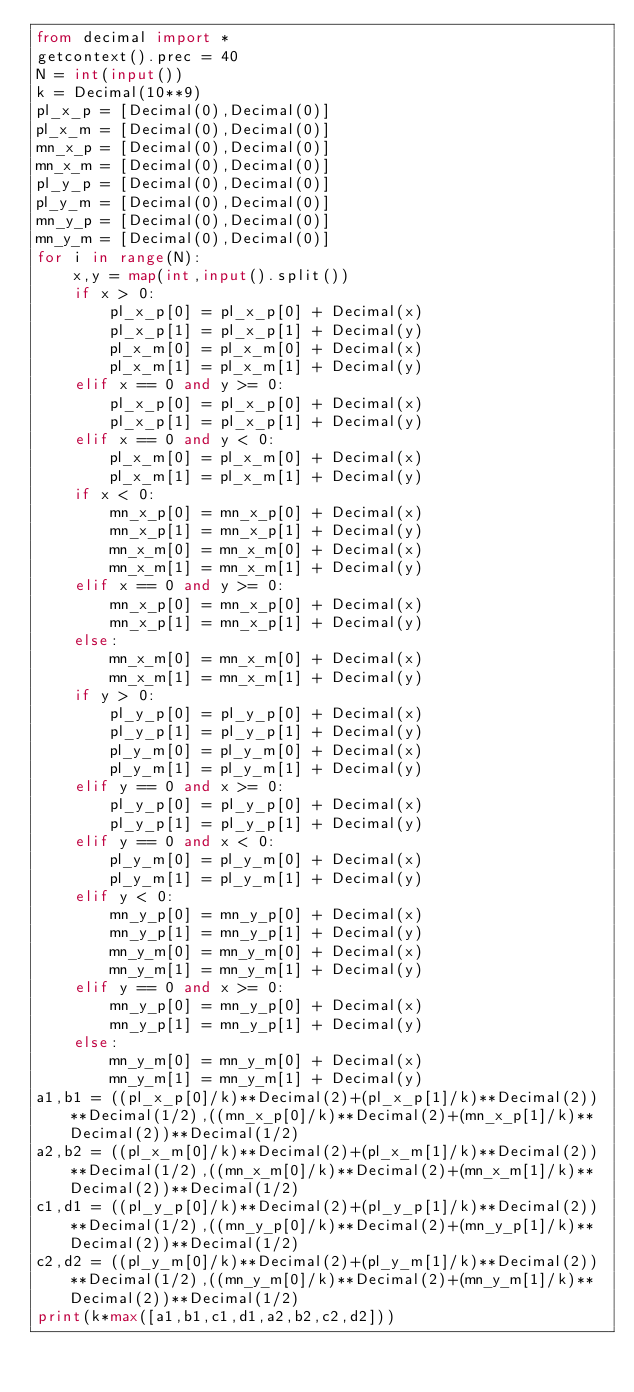<code> <loc_0><loc_0><loc_500><loc_500><_Python_>from decimal import *
getcontext().prec = 40
N = int(input())
k = Decimal(10**9)
pl_x_p = [Decimal(0),Decimal(0)]
pl_x_m = [Decimal(0),Decimal(0)]
mn_x_p = [Decimal(0),Decimal(0)]
mn_x_m = [Decimal(0),Decimal(0)]
pl_y_p = [Decimal(0),Decimal(0)]
pl_y_m = [Decimal(0),Decimal(0)]
mn_y_p = [Decimal(0),Decimal(0)]
mn_y_m = [Decimal(0),Decimal(0)]
for i in range(N):
    x,y = map(int,input().split())
    if x > 0:
        pl_x_p[0] = pl_x_p[0] + Decimal(x)
        pl_x_p[1] = pl_x_p[1] + Decimal(y)
        pl_x_m[0] = pl_x_m[0] + Decimal(x)
        pl_x_m[1] = pl_x_m[1] + Decimal(y)
    elif x == 0 and y >= 0:
        pl_x_p[0] = pl_x_p[0] + Decimal(x)
        pl_x_p[1] = pl_x_p[1] + Decimal(y)
    elif x == 0 and y < 0:
        pl_x_m[0] = pl_x_m[0] + Decimal(x)
        pl_x_m[1] = pl_x_m[1] + Decimal(y)
    if x < 0:
        mn_x_p[0] = mn_x_p[0] + Decimal(x)
        mn_x_p[1] = mn_x_p[1] + Decimal(y)
        mn_x_m[0] = mn_x_m[0] + Decimal(x)
        mn_x_m[1] = mn_x_m[1] + Decimal(y)
    elif x == 0 and y >= 0:
        mn_x_p[0] = mn_x_p[0] + Decimal(x)
        mn_x_p[1] = mn_x_p[1] + Decimal(y)
    else:
        mn_x_m[0] = mn_x_m[0] + Decimal(x)
        mn_x_m[1] = mn_x_m[1] + Decimal(y)
    if y > 0:
        pl_y_p[0] = pl_y_p[0] + Decimal(x)
        pl_y_p[1] = pl_y_p[1] + Decimal(y)
        pl_y_m[0] = pl_y_m[0] + Decimal(x)
        pl_y_m[1] = pl_y_m[1] + Decimal(y)
    elif y == 0 and x >= 0:
        pl_y_p[0] = pl_y_p[0] + Decimal(x)
        pl_y_p[1] = pl_y_p[1] + Decimal(y)
    elif y == 0 and x < 0:
        pl_y_m[0] = pl_y_m[0] + Decimal(x)
        pl_y_m[1] = pl_y_m[1] + Decimal(y)
    elif y < 0:
        mn_y_p[0] = mn_y_p[0] + Decimal(x)
        mn_y_p[1] = mn_y_p[1] + Decimal(y)
        mn_y_m[0] = mn_y_m[0] + Decimal(x)
        mn_y_m[1] = mn_y_m[1] + Decimal(y)
    elif y == 0 and x >= 0:
        mn_y_p[0] = mn_y_p[0] + Decimal(x)
        mn_y_p[1] = mn_y_p[1] + Decimal(y)
    else:
        mn_y_m[0] = mn_y_m[0] + Decimal(x)
        mn_y_m[1] = mn_y_m[1] + Decimal(y)
a1,b1 = ((pl_x_p[0]/k)**Decimal(2)+(pl_x_p[1]/k)**Decimal(2))**Decimal(1/2),((mn_x_p[0]/k)**Decimal(2)+(mn_x_p[1]/k)**Decimal(2))**Decimal(1/2)
a2,b2 = ((pl_x_m[0]/k)**Decimal(2)+(pl_x_m[1]/k)**Decimal(2))**Decimal(1/2),((mn_x_m[0]/k)**Decimal(2)+(mn_x_m[1]/k)**Decimal(2))**Decimal(1/2)
c1,d1 = ((pl_y_p[0]/k)**Decimal(2)+(pl_y_p[1]/k)**Decimal(2))**Decimal(1/2),((mn_y_p[0]/k)**Decimal(2)+(mn_y_p[1]/k)**Decimal(2))**Decimal(1/2)
c2,d2 = ((pl_y_m[0]/k)**Decimal(2)+(pl_y_m[1]/k)**Decimal(2))**Decimal(1/2),((mn_y_m[0]/k)**Decimal(2)+(mn_y_m[1]/k)**Decimal(2))**Decimal(1/2)
print(k*max([a1,b1,c1,d1,a2,b2,c2,d2]))</code> 